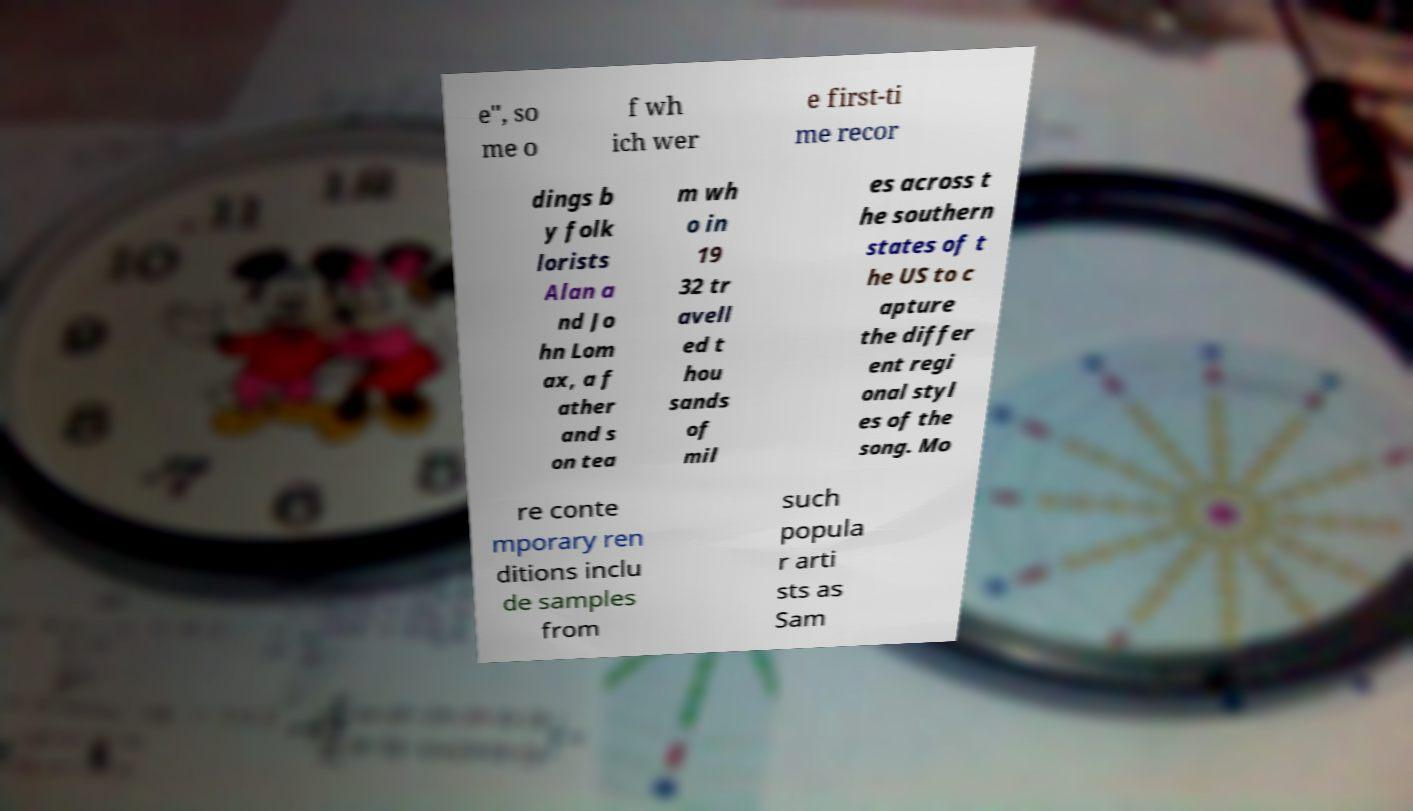What messages or text are displayed in this image? I need them in a readable, typed format. e", so me o f wh ich wer e first-ti me recor dings b y folk lorists Alan a nd Jo hn Lom ax, a f ather and s on tea m wh o in 19 32 tr avell ed t hou sands of mil es across t he southern states of t he US to c apture the differ ent regi onal styl es of the song. Mo re conte mporary ren ditions inclu de samples from such popula r arti sts as Sam 